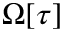<formula> <loc_0><loc_0><loc_500><loc_500>\Omega [ \tau ]</formula> 